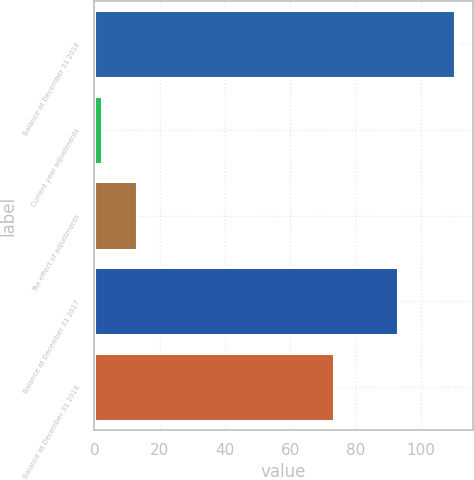<chart> <loc_0><loc_0><loc_500><loc_500><bar_chart><fcel>Balance at December 31 2016<fcel>Current year adjustments<fcel>Tax effect of adjustments<fcel>Balance at December 31 2017<fcel>Balance at December 31 2018<nl><fcel>110.4<fcel>2.4<fcel>13.2<fcel>93<fcel>73.3<nl></chart> 